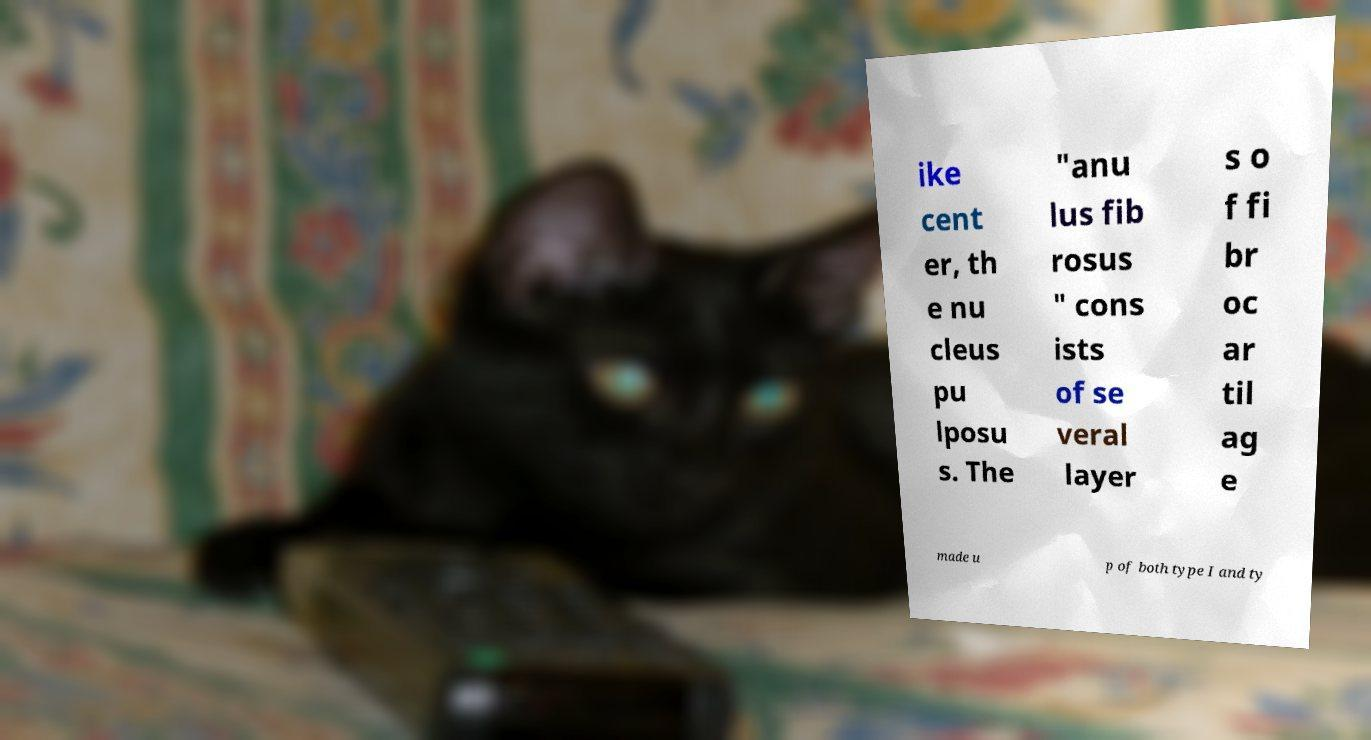Please read and relay the text visible in this image. What does it say? ike cent er, th e nu cleus pu lposu s. The "anu lus fib rosus " cons ists of se veral layer s o f fi br oc ar til ag e made u p of both type I and ty 